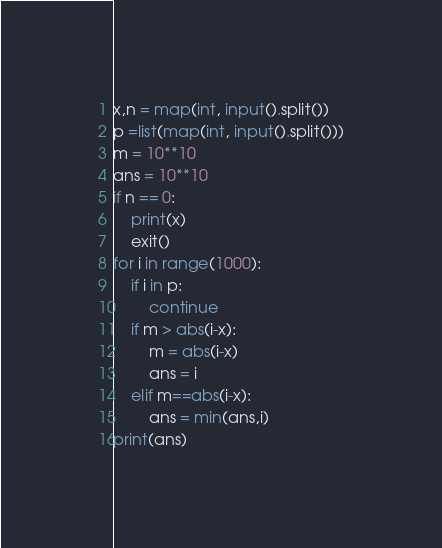<code> <loc_0><loc_0><loc_500><loc_500><_Python_>x,n = map(int, input().split())
p =list(map(int, input().split()))
m = 10**10
ans = 10**10
if n == 0:
    print(x)
    exit()
for i in range(1000):
    if i in p:
        continue
    if m > abs(i-x):
        m = abs(i-x)
        ans = i
    elif m==abs(i-x):
        ans = min(ans,i)
print(ans)
</code> 